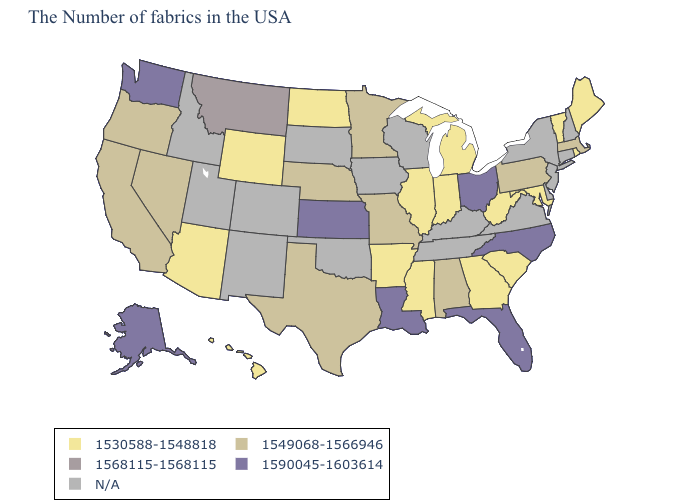What is the lowest value in the Northeast?
Keep it brief. 1530588-1548818. What is the highest value in the USA?
Short answer required. 1590045-1603614. Name the states that have a value in the range 1549068-1566946?
Keep it brief. Massachusetts, Pennsylvania, Alabama, Missouri, Minnesota, Nebraska, Texas, Nevada, California, Oregon. Among the states that border Delaware , which have the highest value?
Write a very short answer. Pennsylvania. Does Florida have the highest value in the USA?
Answer briefly. Yes. Which states have the highest value in the USA?
Keep it brief. North Carolina, Ohio, Florida, Louisiana, Kansas, Washington, Alaska. Among the states that border Iowa , which have the lowest value?
Quick response, please. Illinois. Is the legend a continuous bar?
Answer briefly. No. How many symbols are there in the legend?
Be succinct. 5. What is the lowest value in the MidWest?
Concise answer only. 1530588-1548818. Name the states that have a value in the range 1530588-1548818?
Quick response, please. Maine, Rhode Island, Vermont, Maryland, South Carolina, West Virginia, Georgia, Michigan, Indiana, Illinois, Mississippi, Arkansas, North Dakota, Wyoming, Arizona, Hawaii. Does the map have missing data?
Concise answer only. Yes. Name the states that have a value in the range 1549068-1566946?
Answer briefly. Massachusetts, Pennsylvania, Alabama, Missouri, Minnesota, Nebraska, Texas, Nevada, California, Oregon. Name the states that have a value in the range 1549068-1566946?
Concise answer only. Massachusetts, Pennsylvania, Alabama, Missouri, Minnesota, Nebraska, Texas, Nevada, California, Oregon. 